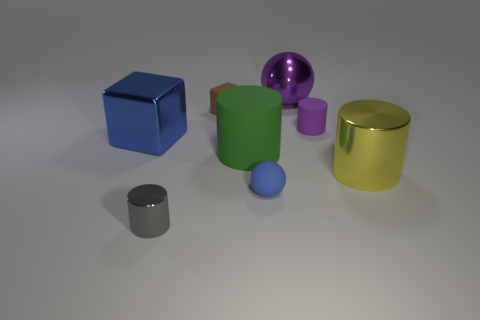There is a thing that is on the left side of the small blue thing and in front of the large yellow object; what is its shape?
Provide a short and direct response. Cylinder. There is a rubber thing in front of the big shiny thing to the right of the matte object that is to the right of the shiny ball; what is its shape?
Provide a short and direct response. Sphere. There is a matte thing that is the same color as the big block; what size is it?
Keep it short and to the point. Small. What number of objects are purple metal spheres or large green balls?
Your answer should be compact. 1. What is the color of the shiny cylinder that is the same size as the brown rubber thing?
Keep it short and to the point. Gray. There is a large yellow object; is it the same shape as the green matte object in front of the tiny purple thing?
Ensure brevity in your answer.  Yes. How many things are either small cylinders that are in front of the yellow thing or metallic things that are behind the tiny blue rubber thing?
Provide a short and direct response. 4. What shape is the small rubber object that is the same color as the big ball?
Ensure brevity in your answer.  Cylinder. What shape is the small object to the left of the brown object?
Provide a short and direct response. Cylinder. There is a big shiny object to the left of the small gray cylinder; is its shape the same as the tiny brown rubber object?
Provide a succinct answer. Yes. 